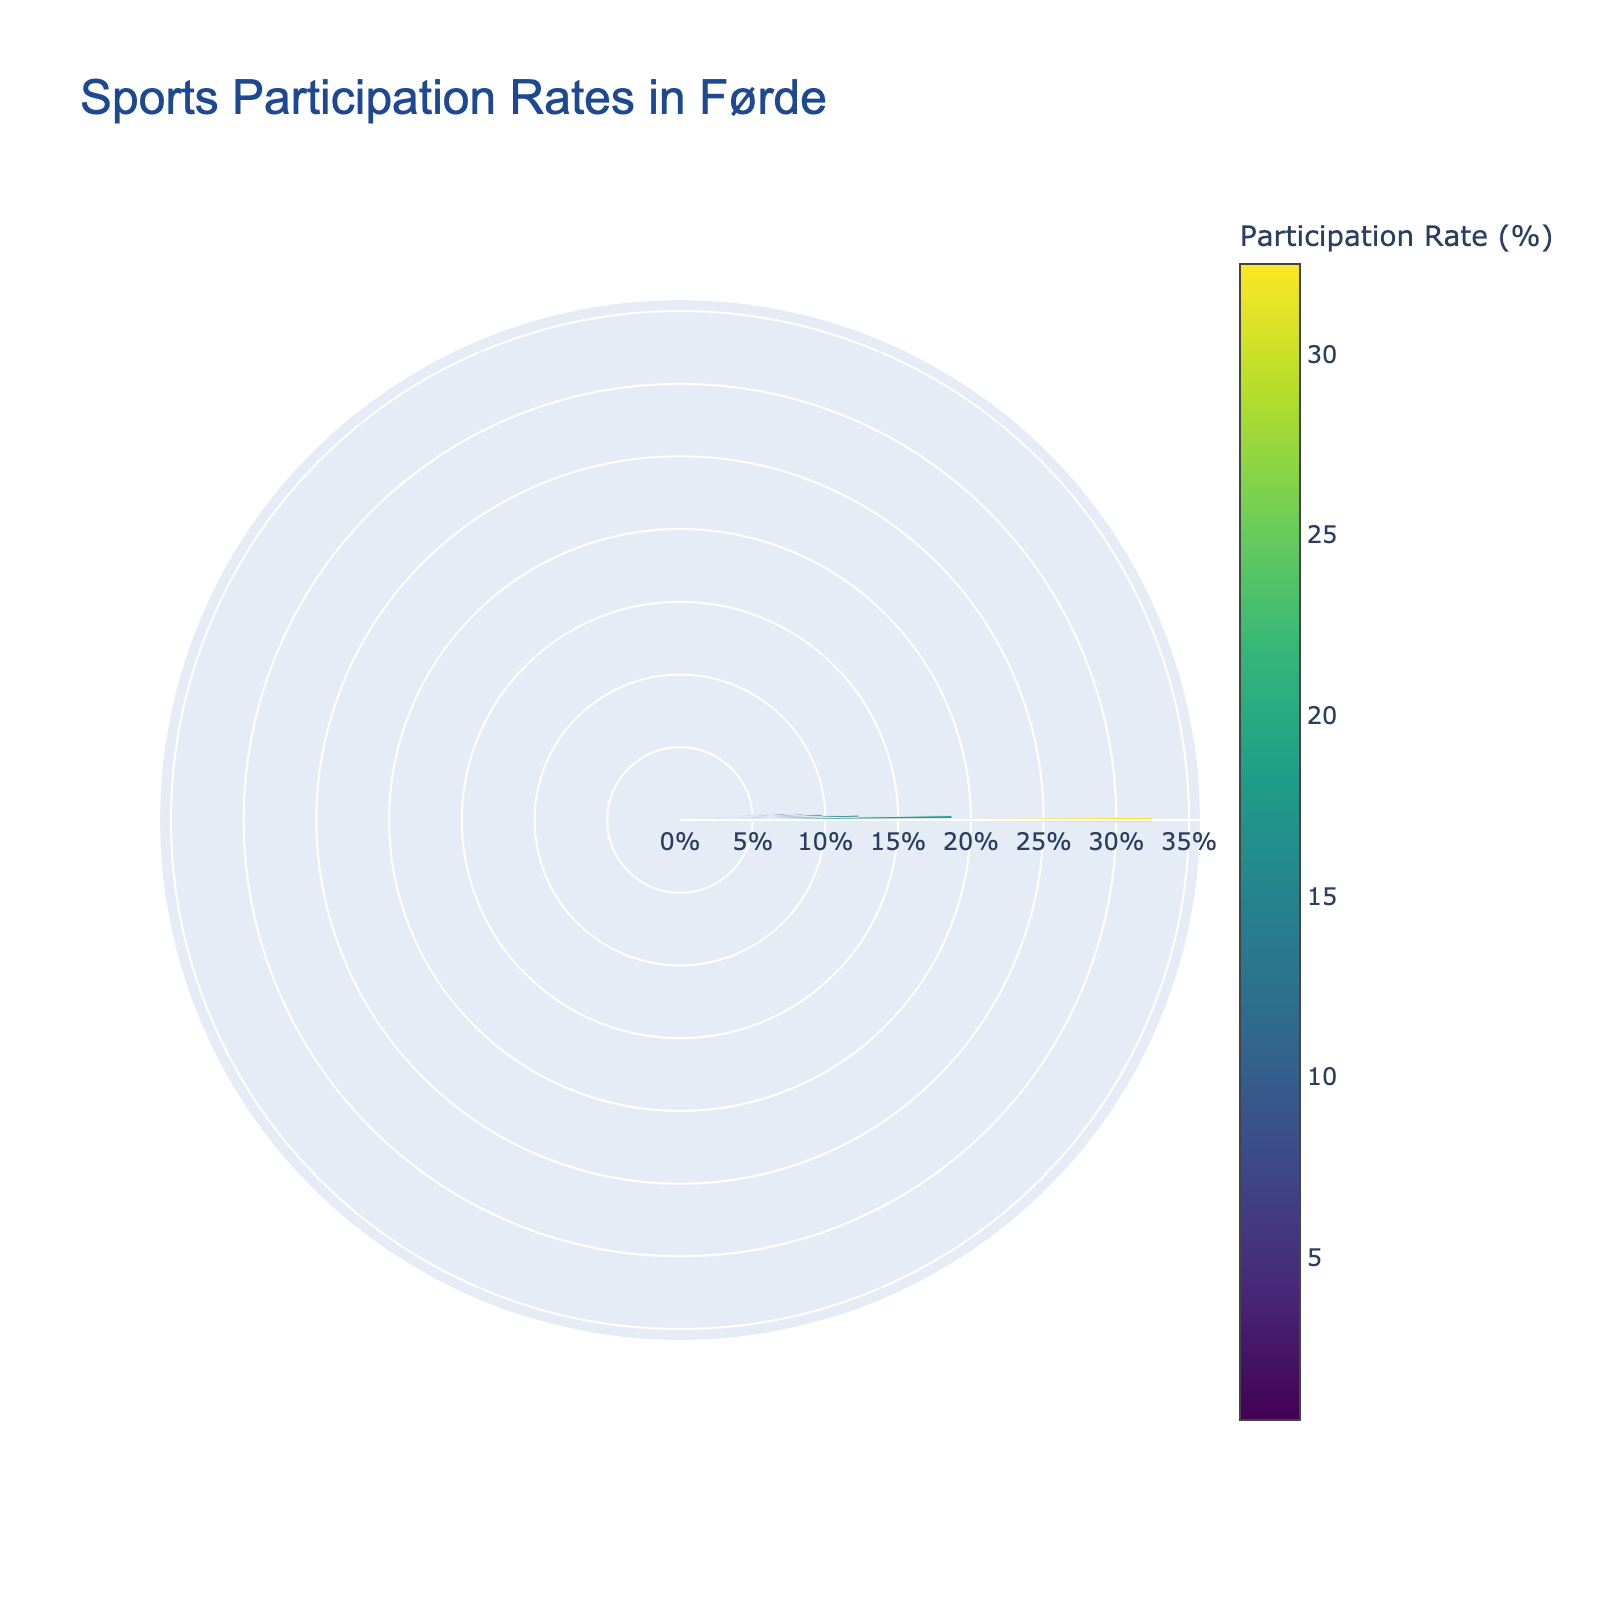What sport has the highest participation rate in Førde? The sport with the tallest bar on the fan chart represents the highest participation rate.
Answer: Football How many sports are represented in the fan chart? Each bar in the fan chart corresponds to a sport; count the number of bars to find the total number of sports.
Answer: 10 Which sport has a lower participation rate, Handball or Swimming? Compare the heights of the bars for Handball and Swimming; the shorter bar indicates the lower participation rate.
Answer: Swimming What is the participation rate for Volleyball? Hover over the bar representing Volleyball to view the participation rate.
Answer: 8.4% What is the total participation rate for the three most popular sports? Sum the participation rates of the top three sports: Football (32.5%), Handball (18.7%), and Athletics (12.3%). 32.5 + 18.7 + 12.3 = 63.5
Answer: 63.5% Which sport has the smallest participation rate, and what is that rate? Identify the shortest bar on the fan chart and note its participation rate.
Answer: Cycling, 0.5% How much higher is the participation rate for Gymnastics compared to Basketball? Subtract Basketball's rate (3.2%) from Gymnastics' rate (5.6%). 5.6 - 3.2 = 2.4
Answer: 2.4% In terms of participation rates, rank the three least popular sports. Identify the sports with the three shortest bars and list them in ascending order: Cycling, Badminton, Basketball.
Answer: Cycling < Badminton < Basketball What is the average participation rate of all the sports? Sum all participation rates and divide by the number of sports: (32.5 + 18.7 + 12.3 + 9.8 + 8.4 + 7.2 + 5.6 + 3.2 + 1.8 + 0.5) / 10 = 10
Answer: 10% Which sports have a participation rate greater than 10%? Identify bars taller than the 10% mark and list the corresponding sports: Football, Handball, Athletics.
Answer: Football, Handball, Athletics 